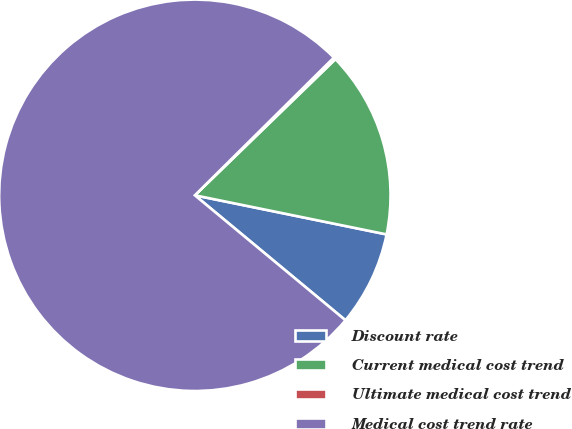<chart> <loc_0><loc_0><loc_500><loc_500><pie_chart><fcel>Discount rate<fcel>Current medical cost trend<fcel>Ultimate medical cost trend<fcel>Medical cost trend rate<nl><fcel>7.82%<fcel>15.45%<fcel>0.18%<fcel>76.55%<nl></chart> 